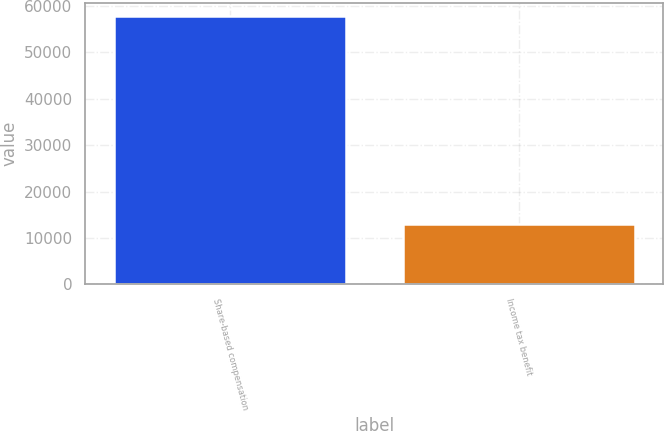Convert chart to OTSL. <chart><loc_0><loc_0><loc_500><loc_500><bar_chart><fcel>Share-based compensation<fcel>Income tax benefit<nl><fcel>57826<fcel>13038<nl></chart> 